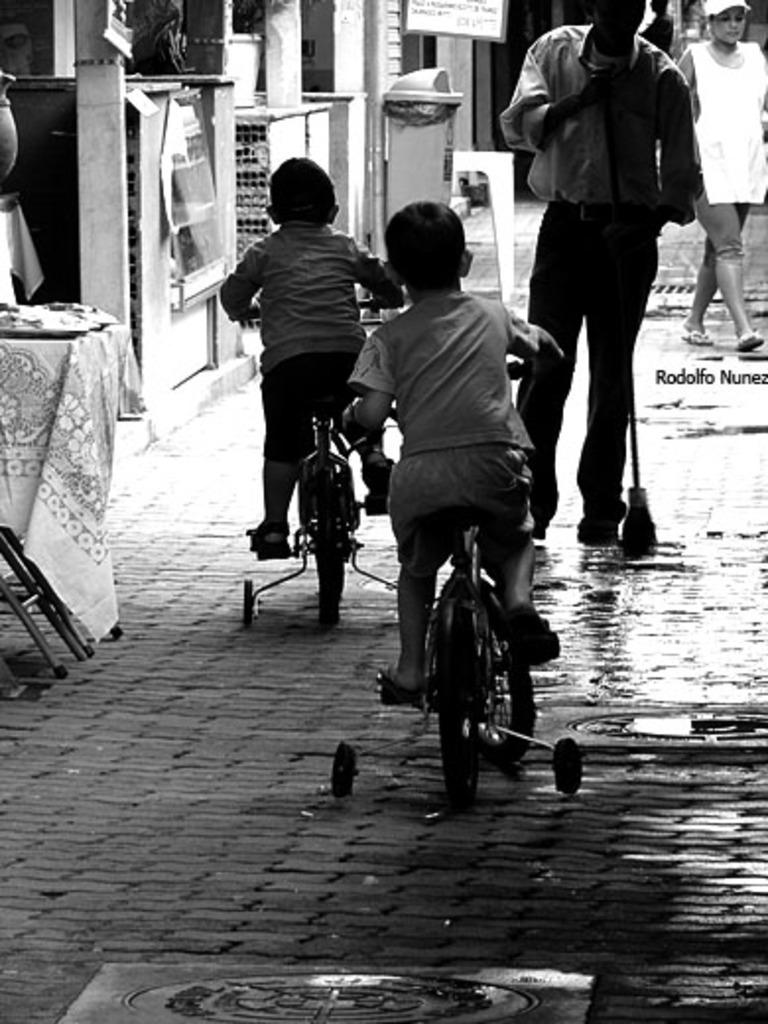How many people are present in the image? There are four people in the image. What are two of the people doing in the image? Two kids are riding bicycles. What are the other two people doing in the image? Two persons are walking on a pathway. What can be seen in the background of the image? There is a dustbin and a hoarding in the background of the image. What type of oatmeal is being served in the image? There is no oatmeal present in the image. Can you see a kitty playing with a ball in the image? There is no kitty or ball present in the image. 